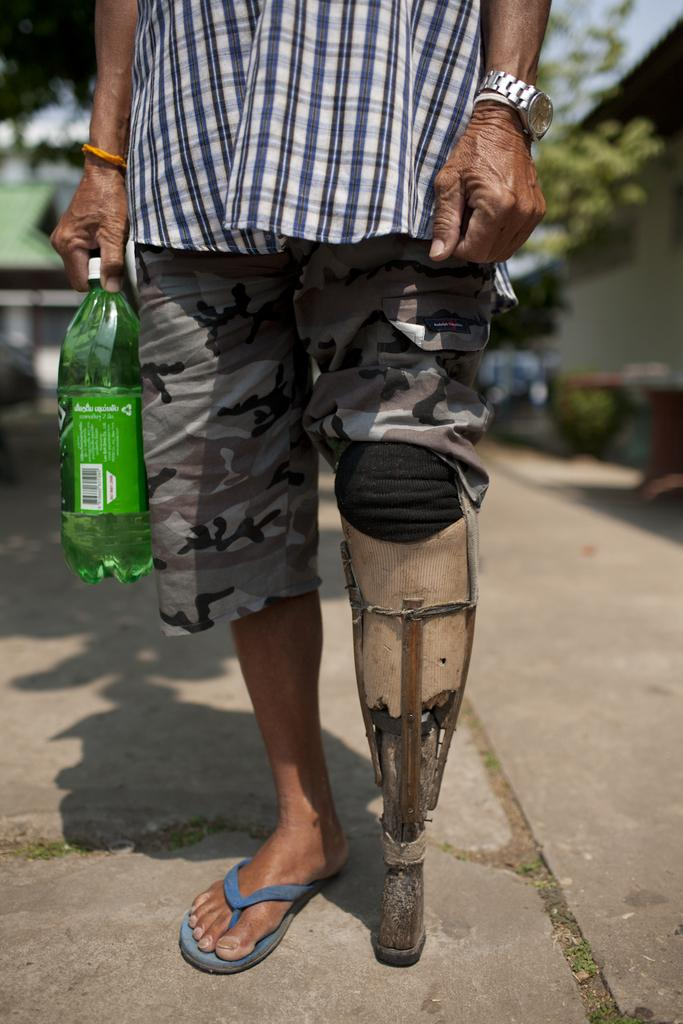What is present in the image? There is a person in the image. What is the person doing in the image? The person is standing. What object is the person holding in the image? The person is holding a green-colored water bottle in his hand. What type of mass is being offered in the image? There is no mass or religious ceremony present in the image. 